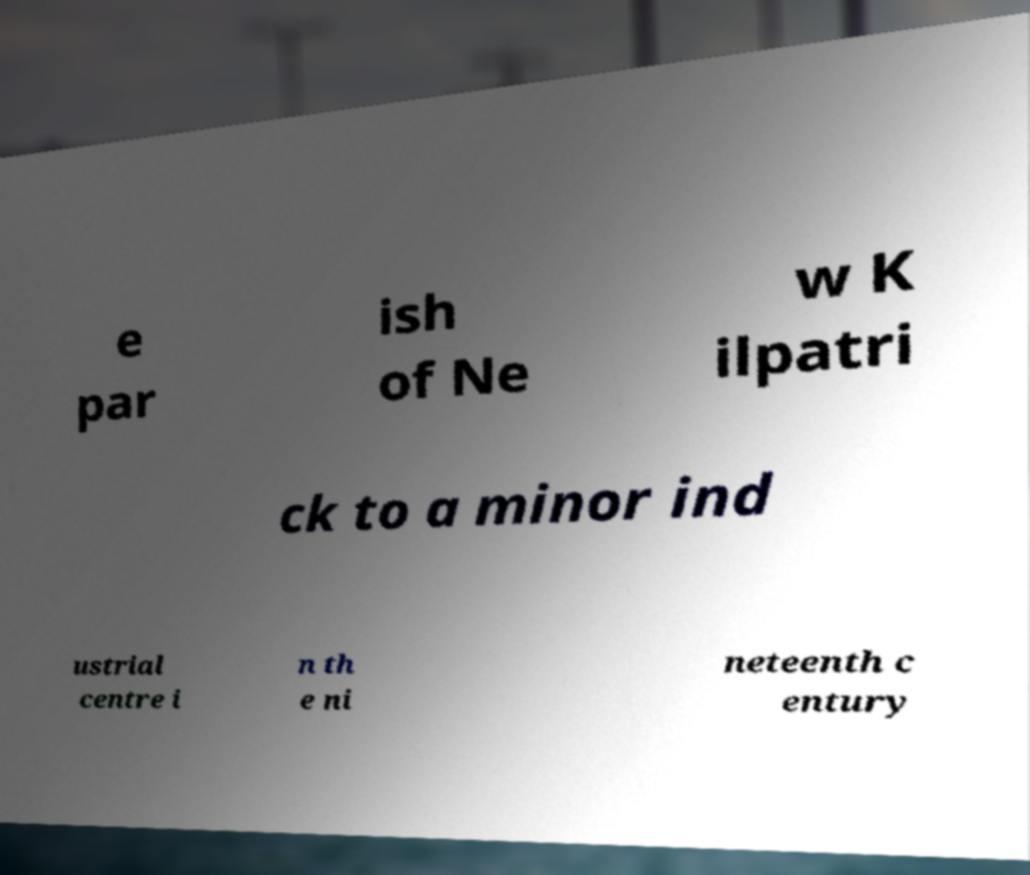For documentation purposes, I need the text within this image transcribed. Could you provide that? e par ish of Ne w K ilpatri ck to a minor ind ustrial centre i n th e ni neteenth c entury 